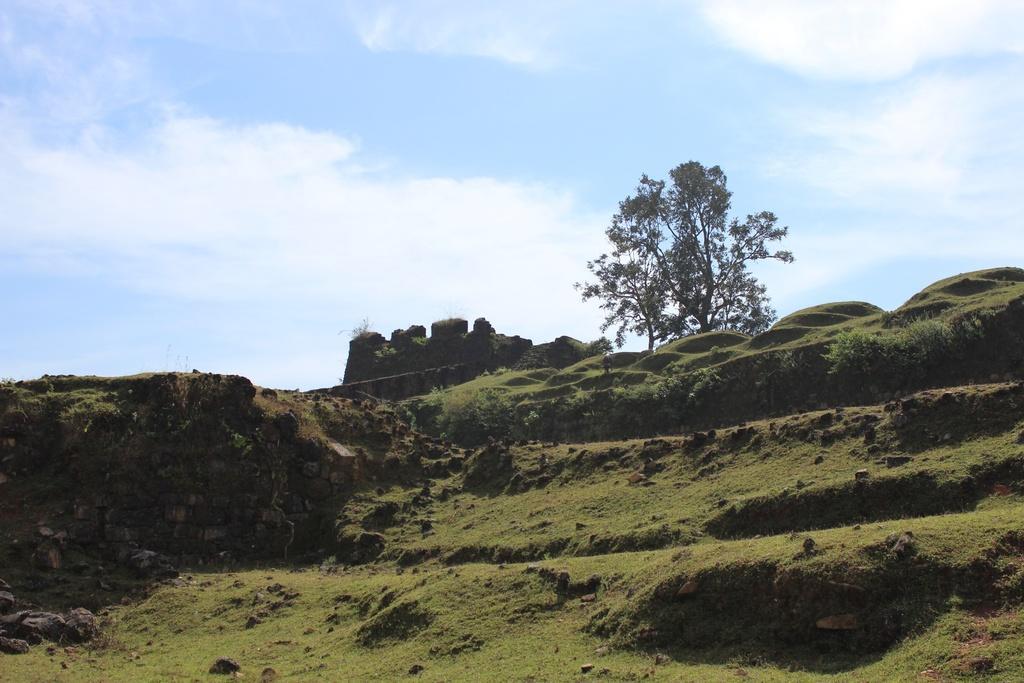In one or two sentences, can you explain what this image depicts? In this image I can see trees and rocks. The sky is in blue and white color. 